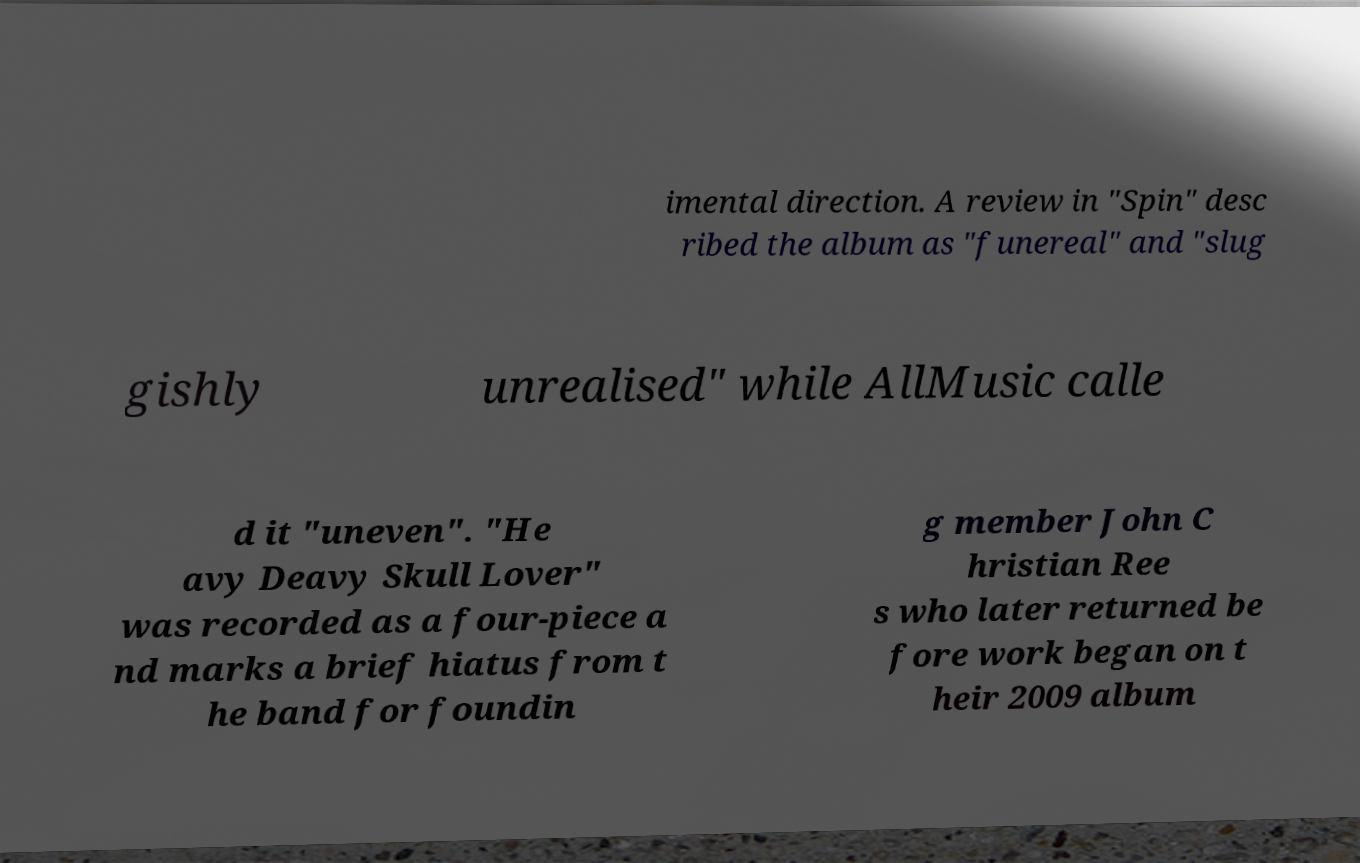Can you accurately transcribe the text from the provided image for me? imental direction. A review in "Spin" desc ribed the album as "funereal" and "slug gishly unrealised" while AllMusic calle d it "uneven". "He avy Deavy Skull Lover" was recorded as a four-piece a nd marks a brief hiatus from t he band for foundin g member John C hristian Ree s who later returned be fore work began on t heir 2009 album 